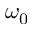<formula> <loc_0><loc_0><loc_500><loc_500>\omega _ { 0 }</formula> 